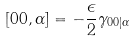<formula> <loc_0><loc_0><loc_500><loc_500>[ 0 0 , \alpha ] = - \frac { \epsilon } { 2 } \gamma _ { 0 0 | \alpha }</formula> 